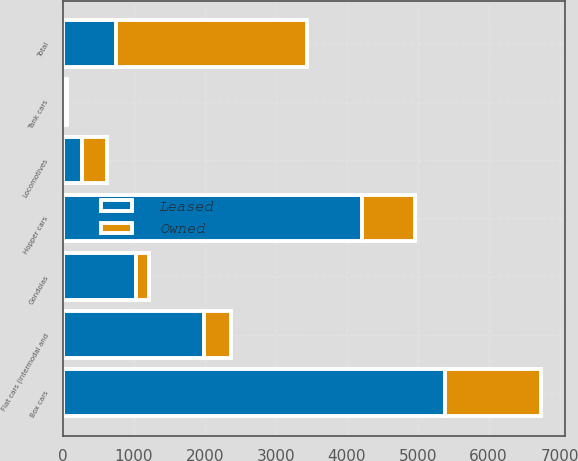Convert chart to OTSL. <chart><loc_0><loc_0><loc_500><loc_500><stacked_bar_chart><ecel><fcel>Locomotives<fcel>Box cars<fcel>Gondolas<fcel>Hopper cars<fcel>Flat cars (intermodal and<fcel>Tank cars<fcel>Total<nl><fcel>Leased<fcel>272<fcel>5386<fcel>1037<fcel>4222<fcel>1985<fcel>24<fcel>743<nl><fcel>Owned<fcel>348<fcel>1356<fcel>176<fcel>743<fcel>388<fcel>30<fcel>2696<nl></chart> 